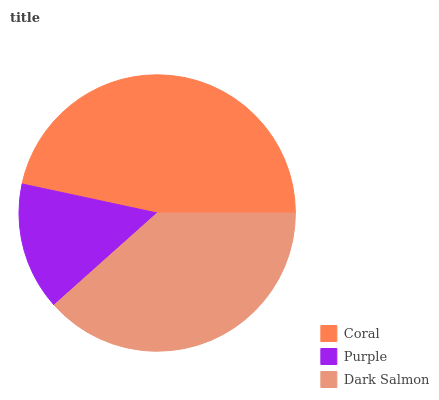Is Purple the minimum?
Answer yes or no. Yes. Is Coral the maximum?
Answer yes or no. Yes. Is Dark Salmon the minimum?
Answer yes or no. No. Is Dark Salmon the maximum?
Answer yes or no. No. Is Dark Salmon greater than Purple?
Answer yes or no. Yes. Is Purple less than Dark Salmon?
Answer yes or no. Yes. Is Purple greater than Dark Salmon?
Answer yes or no. No. Is Dark Salmon less than Purple?
Answer yes or no. No. Is Dark Salmon the high median?
Answer yes or no. Yes. Is Dark Salmon the low median?
Answer yes or no. Yes. Is Coral the high median?
Answer yes or no. No. Is Purple the low median?
Answer yes or no. No. 